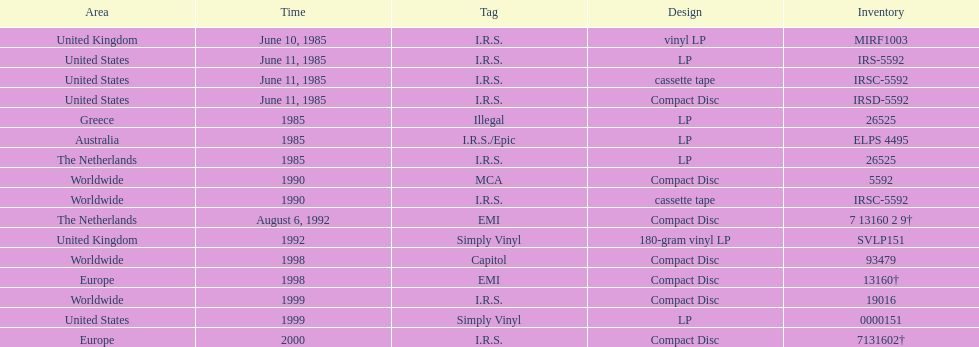How many more releases were in compact disc format than cassette tape? 5. 